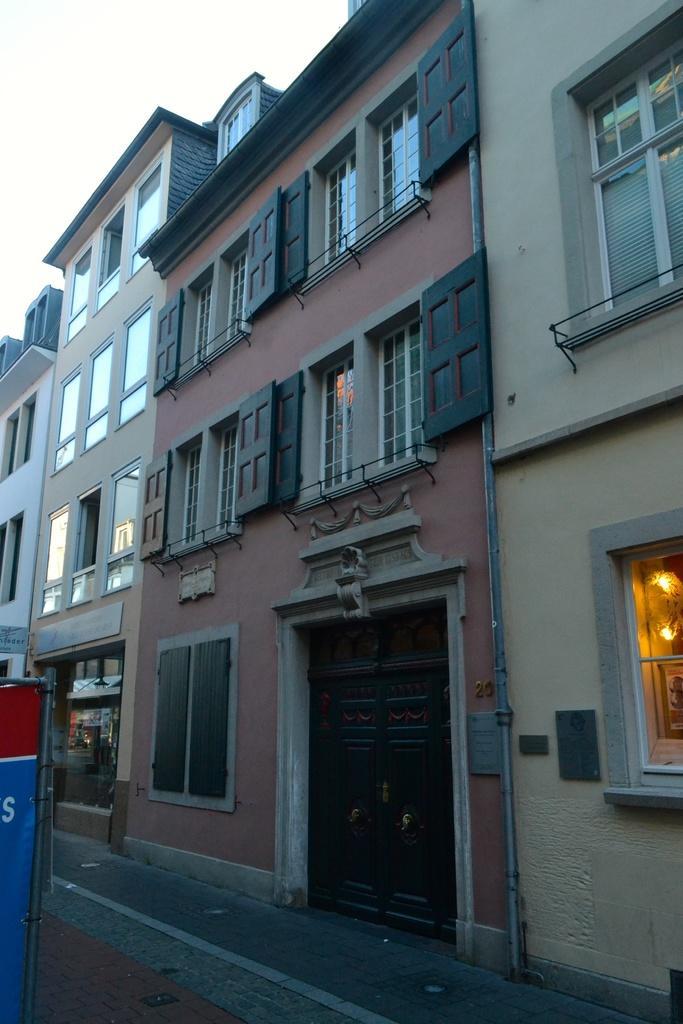Describe this image in one or two sentences. In this image we can see some buildings with glass windows, doors, lights and other objects. On the left side of the image there is an object. At the bottom of the image there is a road and a walkway. At the top of the image there is the sky. 